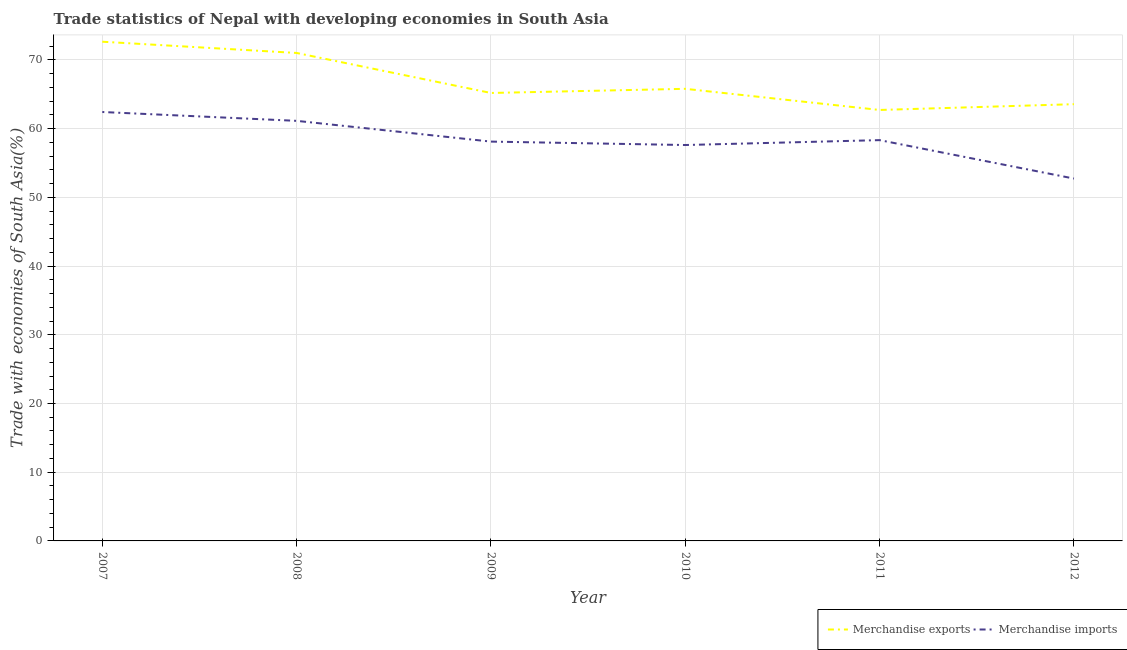Does the line corresponding to merchandise exports intersect with the line corresponding to merchandise imports?
Your answer should be compact. No. What is the merchandise exports in 2012?
Provide a short and direct response. 63.57. Across all years, what is the maximum merchandise exports?
Keep it short and to the point. 72.66. Across all years, what is the minimum merchandise exports?
Provide a short and direct response. 62.72. In which year was the merchandise imports minimum?
Keep it short and to the point. 2012. What is the total merchandise imports in the graph?
Ensure brevity in your answer.  350.39. What is the difference between the merchandise imports in 2008 and that in 2010?
Make the answer very short. 3.52. What is the difference between the merchandise imports in 2007 and the merchandise exports in 2008?
Offer a terse response. -8.59. What is the average merchandise imports per year?
Provide a succinct answer. 58.4. In the year 2009, what is the difference between the merchandise exports and merchandise imports?
Your response must be concise. 7.08. What is the ratio of the merchandise imports in 2008 to that in 2011?
Your answer should be compact. 1.05. Is the merchandise imports in 2008 less than that in 2010?
Offer a terse response. No. What is the difference between the highest and the second highest merchandise imports?
Your answer should be very brief. 1.29. What is the difference between the highest and the lowest merchandise imports?
Provide a short and direct response. 9.69. In how many years, is the merchandise exports greater than the average merchandise exports taken over all years?
Your answer should be compact. 2. Is the sum of the merchandise exports in 2008 and 2009 greater than the maximum merchandise imports across all years?
Ensure brevity in your answer.  Yes. Is the merchandise imports strictly less than the merchandise exports over the years?
Offer a terse response. Yes. How many years are there in the graph?
Keep it short and to the point. 6. What is the difference between two consecutive major ticks on the Y-axis?
Your answer should be compact. 10. Are the values on the major ticks of Y-axis written in scientific E-notation?
Your answer should be very brief. No. Does the graph contain any zero values?
Offer a terse response. No. Does the graph contain grids?
Make the answer very short. Yes. What is the title of the graph?
Keep it short and to the point. Trade statistics of Nepal with developing economies in South Asia. Does "Under-5(male)" appear as one of the legend labels in the graph?
Offer a very short reply. No. What is the label or title of the X-axis?
Ensure brevity in your answer.  Year. What is the label or title of the Y-axis?
Provide a succinct answer. Trade with economies of South Asia(%). What is the Trade with economies of South Asia(%) of Merchandise exports in 2007?
Provide a short and direct response. 72.66. What is the Trade with economies of South Asia(%) of Merchandise imports in 2007?
Provide a short and direct response. 62.43. What is the Trade with economies of South Asia(%) in Merchandise exports in 2008?
Offer a terse response. 71.02. What is the Trade with economies of South Asia(%) in Merchandise imports in 2008?
Your answer should be very brief. 61.14. What is the Trade with economies of South Asia(%) in Merchandise exports in 2009?
Your response must be concise. 65.2. What is the Trade with economies of South Asia(%) in Merchandise imports in 2009?
Ensure brevity in your answer.  58.12. What is the Trade with economies of South Asia(%) in Merchandise exports in 2010?
Offer a very short reply. 65.8. What is the Trade with economies of South Asia(%) of Merchandise imports in 2010?
Keep it short and to the point. 57.62. What is the Trade with economies of South Asia(%) of Merchandise exports in 2011?
Provide a succinct answer. 62.72. What is the Trade with economies of South Asia(%) in Merchandise imports in 2011?
Offer a terse response. 58.33. What is the Trade with economies of South Asia(%) of Merchandise exports in 2012?
Keep it short and to the point. 63.57. What is the Trade with economies of South Asia(%) of Merchandise imports in 2012?
Keep it short and to the point. 52.74. Across all years, what is the maximum Trade with economies of South Asia(%) in Merchandise exports?
Your answer should be compact. 72.66. Across all years, what is the maximum Trade with economies of South Asia(%) of Merchandise imports?
Give a very brief answer. 62.43. Across all years, what is the minimum Trade with economies of South Asia(%) of Merchandise exports?
Provide a succinct answer. 62.72. Across all years, what is the minimum Trade with economies of South Asia(%) of Merchandise imports?
Offer a terse response. 52.74. What is the total Trade with economies of South Asia(%) in Merchandise exports in the graph?
Your answer should be very brief. 400.97. What is the total Trade with economies of South Asia(%) of Merchandise imports in the graph?
Offer a very short reply. 350.39. What is the difference between the Trade with economies of South Asia(%) of Merchandise exports in 2007 and that in 2008?
Your response must be concise. 1.64. What is the difference between the Trade with economies of South Asia(%) in Merchandise imports in 2007 and that in 2008?
Make the answer very short. 1.29. What is the difference between the Trade with economies of South Asia(%) in Merchandise exports in 2007 and that in 2009?
Your response must be concise. 7.46. What is the difference between the Trade with economies of South Asia(%) of Merchandise imports in 2007 and that in 2009?
Keep it short and to the point. 4.31. What is the difference between the Trade with economies of South Asia(%) in Merchandise exports in 2007 and that in 2010?
Your answer should be compact. 6.86. What is the difference between the Trade with economies of South Asia(%) of Merchandise imports in 2007 and that in 2010?
Provide a succinct answer. 4.81. What is the difference between the Trade with economies of South Asia(%) in Merchandise exports in 2007 and that in 2011?
Offer a very short reply. 9.93. What is the difference between the Trade with economies of South Asia(%) in Merchandise imports in 2007 and that in 2011?
Your response must be concise. 4.09. What is the difference between the Trade with economies of South Asia(%) of Merchandise exports in 2007 and that in 2012?
Offer a very short reply. 9.09. What is the difference between the Trade with economies of South Asia(%) of Merchandise imports in 2007 and that in 2012?
Ensure brevity in your answer.  9.69. What is the difference between the Trade with economies of South Asia(%) in Merchandise exports in 2008 and that in 2009?
Your answer should be very brief. 5.82. What is the difference between the Trade with economies of South Asia(%) in Merchandise imports in 2008 and that in 2009?
Your response must be concise. 3.02. What is the difference between the Trade with economies of South Asia(%) of Merchandise exports in 2008 and that in 2010?
Your answer should be very brief. 5.22. What is the difference between the Trade with economies of South Asia(%) in Merchandise imports in 2008 and that in 2010?
Ensure brevity in your answer.  3.52. What is the difference between the Trade with economies of South Asia(%) of Merchandise exports in 2008 and that in 2011?
Ensure brevity in your answer.  8.3. What is the difference between the Trade with economies of South Asia(%) in Merchandise imports in 2008 and that in 2011?
Keep it short and to the point. 2.81. What is the difference between the Trade with economies of South Asia(%) of Merchandise exports in 2008 and that in 2012?
Make the answer very short. 7.45. What is the difference between the Trade with economies of South Asia(%) of Merchandise imports in 2008 and that in 2012?
Your answer should be very brief. 8.4. What is the difference between the Trade with economies of South Asia(%) of Merchandise exports in 2009 and that in 2010?
Give a very brief answer. -0.6. What is the difference between the Trade with economies of South Asia(%) in Merchandise imports in 2009 and that in 2010?
Your answer should be compact. 0.5. What is the difference between the Trade with economies of South Asia(%) of Merchandise exports in 2009 and that in 2011?
Provide a succinct answer. 2.47. What is the difference between the Trade with economies of South Asia(%) in Merchandise imports in 2009 and that in 2011?
Your response must be concise. -0.21. What is the difference between the Trade with economies of South Asia(%) of Merchandise exports in 2009 and that in 2012?
Provide a succinct answer. 1.63. What is the difference between the Trade with economies of South Asia(%) in Merchandise imports in 2009 and that in 2012?
Provide a succinct answer. 5.38. What is the difference between the Trade with economies of South Asia(%) in Merchandise exports in 2010 and that in 2011?
Your answer should be compact. 3.08. What is the difference between the Trade with economies of South Asia(%) in Merchandise imports in 2010 and that in 2011?
Provide a short and direct response. -0.71. What is the difference between the Trade with economies of South Asia(%) of Merchandise exports in 2010 and that in 2012?
Your answer should be very brief. 2.24. What is the difference between the Trade with economies of South Asia(%) in Merchandise imports in 2010 and that in 2012?
Your answer should be compact. 4.88. What is the difference between the Trade with economies of South Asia(%) in Merchandise exports in 2011 and that in 2012?
Offer a very short reply. -0.84. What is the difference between the Trade with economies of South Asia(%) in Merchandise imports in 2011 and that in 2012?
Offer a terse response. 5.59. What is the difference between the Trade with economies of South Asia(%) in Merchandise exports in 2007 and the Trade with economies of South Asia(%) in Merchandise imports in 2008?
Provide a succinct answer. 11.52. What is the difference between the Trade with economies of South Asia(%) in Merchandise exports in 2007 and the Trade with economies of South Asia(%) in Merchandise imports in 2009?
Provide a short and direct response. 14.54. What is the difference between the Trade with economies of South Asia(%) in Merchandise exports in 2007 and the Trade with economies of South Asia(%) in Merchandise imports in 2010?
Your response must be concise. 15.04. What is the difference between the Trade with economies of South Asia(%) of Merchandise exports in 2007 and the Trade with economies of South Asia(%) of Merchandise imports in 2011?
Your answer should be very brief. 14.32. What is the difference between the Trade with economies of South Asia(%) of Merchandise exports in 2007 and the Trade with economies of South Asia(%) of Merchandise imports in 2012?
Your response must be concise. 19.92. What is the difference between the Trade with economies of South Asia(%) in Merchandise exports in 2008 and the Trade with economies of South Asia(%) in Merchandise imports in 2009?
Make the answer very short. 12.9. What is the difference between the Trade with economies of South Asia(%) of Merchandise exports in 2008 and the Trade with economies of South Asia(%) of Merchandise imports in 2010?
Your answer should be very brief. 13.4. What is the difference between the Trade with economies of South Asia(%) in Merchandise exports in 2008 and the Trade with economies of South Asia(%) in Merchandise imports in 2011?
Offer a very short reply. 12.69. What is the difference between the Trade with economies of South Asia(%) in Merchandise exports in 2008 and the Trade with economies of South Asia(%) in Merchandise imports in 2012?
Keep it short and to the point. 18.28. What is the difference between the Trade with economies of South Asia(%) in Merchandise exports in 2009 and the Trade with economies of South Asia(%) in Merchandise imports in 2010?
Offer a very short reply. 7.58. What is the difference between the Trade with economies of South Asia(%) of Merchandise exports in 2009 and the Trade with economies of South Asia(%) of Merchandise imports in 2011?
Your answer should be compact. 6.86. What is the difference between the Trade with economies of South Asia(%) in Merchandise exports in 2009 and the Trade with economies of South Asia(%) in Merchandise imports in 2012?
Ensure brevity in your answer.  12.46. What is the difference between the Trade with economies of South Asia(%) of Merchandise exports in 2010 and the Trade with economies of South Asia(%) of Merchandise imports in 2011?
Make the answer very short. 7.47. What is the difference between the Trade with economies of South Asia(%) of Merchandise exports in 2010 and the Trade with economies of South Asia(%) of Merchandise imports in 2012?
Provide a short and direct response. 13.06. What is the difference between the Trade with economies of South Asia(%) of Merchandise exports in 2011 and the Trade with economies of South Asia(%) of Merchandise imports in 2012?
Make the answer very short. 9.98. What is the average Trade with economies of South Asia(%) in Merchandise exports per year?
Your response must be concise. 66.83. What is the average Trade with economies of South Asia(%) in Merchandise imports per year?
Provide a succinct answer. 58.4. In the year 2007, what is the difference between the Trade with economies of South Asia(%) in Merchandise exports and Trade with economies of South Asia(%) in Merchandise imports?
Provide a succinct answer. 10.23. In the year 2008, what is the difference between the Trade with economies of South Asia(%) in Merchandise exports and Trade with economies of South Asia(%) in Merchandise imports?
Make the answer very short. 9.88. In the year 2009, what is the difference between the Trade with economies of South Asia(%) of Merchandise exports and Trade with economies of South Asia(%) of Merchandise imports?
Your answer should be very brief. 7.08. In the year 2010, what is the difference between the Trade with economies of South Asia(%) of Merchandise exports and Trade with economies of South Asia(%) of Merchandise imports?
Ensure brevity in your answer.  8.18. In the year 2011, what is the difference between the Trade with economies of South Asia(%) in Merchandise exports and Trade with economies of South Asia(%) in Merchandise imports?
Offer a very short reply. 4.39. In the year 2012, what is the difference between the Trade with economies of South Asia(%) of Merchandise exports and Trade with economies of South Asia(%) of Merchandise imports?
Your response must be concise. 10.83. What is the ratio of the Trade with economies of South Asia(%) of Merchandise exports in 2007 to that in 2008?
Make the answer very short. 1.02. What is the ratio of the Trade with economies of South Asia(%) of Merchandise imports in 2007 to that in 2008?
Keep it short and to the point. 1.02. What is the ratio of the Trade with economies of South Asia(%) in Merchandise exports in 2007 to that in 2009?
Offer a very short reply. 1.11. What is the ratio of the Trade with economies of South Asia(%) of Merchandise imports in 2007 to that in 2009?
Your response must be concise. 1.07. What is the ratio of the Trade with economies of South Asia(%) in Merchandise exports in 2007 to that in 2010?
Ensure brevity in your answer.  1.1. What is the ratio of the Trade with economies of South Asia(%) in Merchandise imports in 2007 to that in 2010?
Your response must be concise. 1.08. What is the ratio of the Trade with economies of South Asia(%) of Merchandise exports in 2007 to that in 2011?
Give a very brief answer. 1.16. What is the ratio of the Trade with economies of South Asia(%) in Merchandise imports in 2007 to that in 2011?
Give a very brief answer. 1.07. What is the ratio of the Trade with economies of South Asia(%) of Merchandise exports in 2007 to that in 2012?
Give a very brief answer. 1.14. What is the ratio of the Trade with economies of South Asia(%) in Merchandise imports in 2007 to that in 2012?
Your answer should be compact. 1.18. What is the ratio of the Trade with economies of South Asia(%) of Merchandise exports in 2008 to that in 2009?
Ensure brevity in your answer.  1.09. What is the ratio of the Trade with economies of South Asia(%) in Merchandise imports in 2008 to that in 2009?
Keep it short and to the point. 1.05. What is the ratio of the Trade with economies of South Asia(%) in Merchandise exports in 2008 to that in 2010?
Provide a short and direct response. 1.08. What is the ratio of the Trade with economies of South Asia(%) of Merchandise imports in 2008 to that in 2010?
Give a very brief answer. 1.06. What is the ratio of the Trade with economies of South Asia(%) in Merchandise exports in 2008 to that in 2011?
Your answer should be very brief. 1.13. What is the ratio of the Trade with economies of South Asia(%) in Merchandise imports in 2008 to that in 2011?
Your response must be concise. 1.05. What is the ratio of the Trade with economies of South Asia(%) in Merchandise exports in 2008 to that in 2012?
Offer a terse response. 1.12. What is the ratio of the Trade with economies of South Asia(%) in Merchandise imports in 2008 to that in 2012?
Offer a very short reply. 1.16. What is the ratio of the Trade with economies of South Asia(%) in Merchandise exports in 2009 to that in 2010?
Ensure brevity in your answer.  0.99. What is the ratio of the Trade with economies of South Asia(%) in Merchandise imports in 2009 to that in 2010?
Your answer should be very brief. 1.01. What is the ratio of the Trade with economies of South Asia(%) in Merchandise exports in 2009 to that in 2011?
Ensure brevity in your answer.  1.04. What is the ratio of the Trade with economies of South Asia(%) in Merchandise imports in 2009 to that in 2011?
Your answer should be very brief. 1. What is the ratio of the Trade with economies of South Asia(%) of Merchandise exports in 2009 to that in 2012?
Your answer should be very brief. 1.03. What is the ratio of the Trade with economies of South Asia(%) in Merchandise imports in 2009 to that in 2012?
Provide a succinct answer. 1.1. What is the ratio of the Trade with economies of South Asia(%) of Merchandise exports in 2010 to that in 2011?
Provide a succinct answer. 1.05. What is the ratio of the Trade with economies of South Asia(%) of Merchandise exports in 2010 to that in 2012?
Ensure brevity in your answer.  1.04. What is the ratio of the Trade with economies of South Asia(%) of Merchandise imports in 2010 to that in 2012?
Keep it short and to the point. 1.09. What is the ratio of the Trade with economies of South Asia(%) in Merchandise imports in 2011 to that in 2012?
Your answer should be compact. 1.11. What is the difference between the highest and the second highest Trade with economies of South Asia(%) of Merchandise exports?
Keep it short and to the point. 1.64. What is the difference between the highest and the second highest Trade with economies of South Asia(%) in Merchandise imports?
Your answer should be very brief. 1.29. What is the difference between the highest and the lowest Trade with economies of South Asia(%) of Merchandise exports?
Your response must be concise. 9.93. What is the difference between the highest and the lowest Trade with economies of South Asia(%) of Merchandise imports?
Offer a terse response. 9.69. 